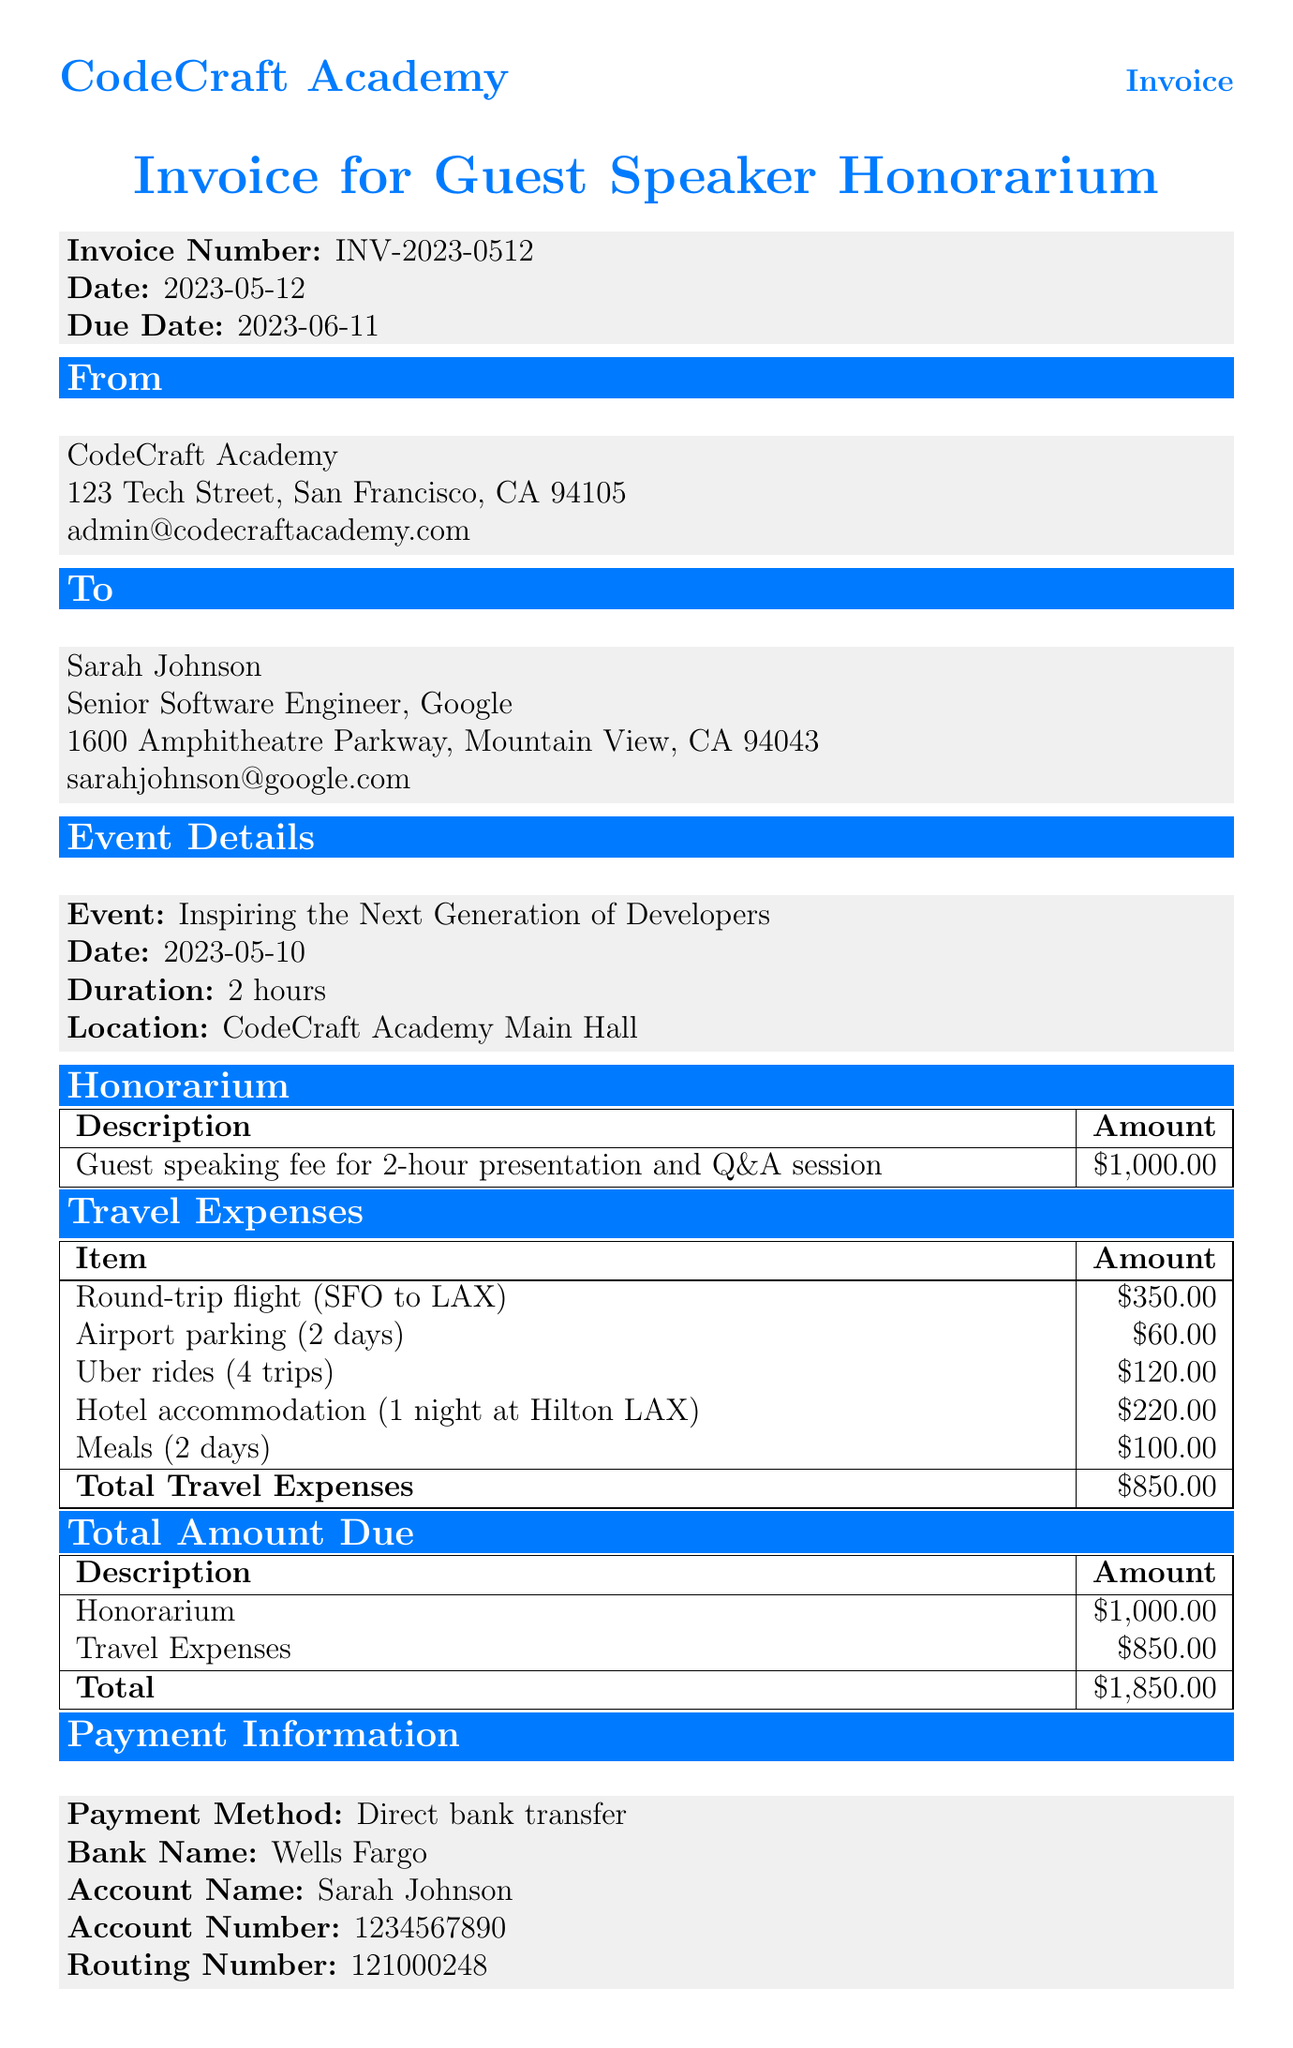What is the invoice number? The invoice number is explicitly stated in the document under invoice details as INV-2023-0512.
Answer: INV-2023-0512 Who is the guest speaker? The guest speaker's name is provided in the guest speaker section as Sarah Johnson.
Answer: Sarah Johnson What is the total amount due? The total amount due is calculated as the sum of the honorarium and travel expenses in the document, totaling $1850.
Answer: $1850 What company does the guest speaker work for? The company for the guest speaker is listed in the document as Google.
Answer: Google What is the date of the event? The date of the event is specified in the document as 2023-05-10.
Answer: 2023-05-10 What is the travel expense for Uber rides? The travel expense for Uber rides is specifically stated in the travel expenses section as $120.
Answer: $120 How many days is the airport parking charged for? The airport parking charge is documented for a duration of 2 days.
Answer: 2 days What is the payment method? The payment method is outlined in the payment information section as Direct bank transfer.
Answer: Direct bank transfer What accommodations were made for the guest speaker? The document lists hotel accommodation for 1 night at Hilton LAX as part of the travel expenses.
Answer: 1 night at Hilton LAX 